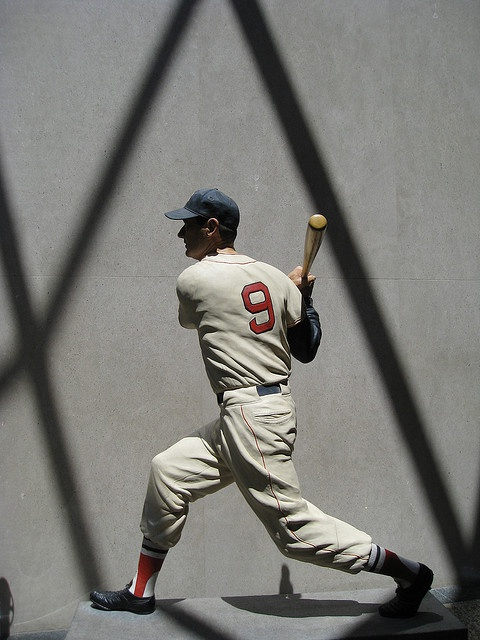Describe the objects in this image and their specific colors. I can see people in gray, black, lightgray, and darkgray tones and baseball bat in gray and black tones in this image. 